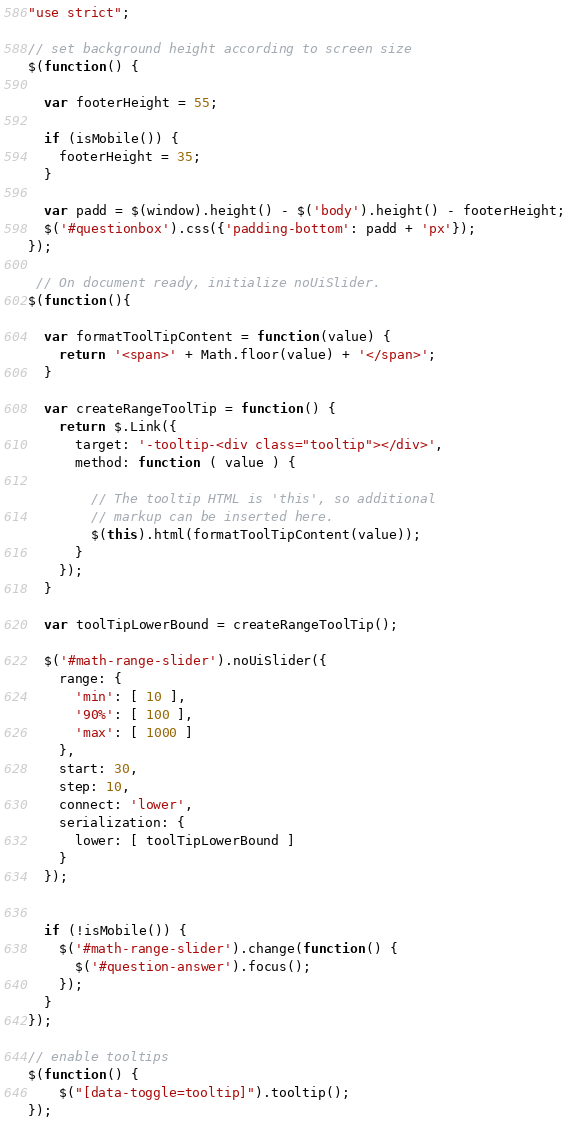<code> <loc_0><loc_0><loc_500><loc_500><_JavaScript_>"use strict";

// set background height according to screen size
$(function() {

  var footerHeight = 55;

  if (isMobile()) {
    footerHeight = 35;
  }

  var padd = $(window).height() - $('body').height() - footerHeight;
  $('#questionbox').css({'padding-bottom': padd + 'px'});
});

 // On document ready, initialize noUiSlider.
$(function(){

  var formatToolTipContent = function(value) {
    return '<span>' + Math.floor(value) + '</span>';
  }

  var createRangeToolTip = function() {
    return $.Link({
      target: '-tooltip-<div class="tooltip"></div>',
      method: function ( value ) {

        // The tooltip HTML is 'this', so additional
        // markup can be inserted here.
        $(this).html(formatToolTipContent(value));
      }
    });
  }

  var toolTipLowerBound = createRangeToolTip();

  $('#math-range-slider').noUiSlider({
    range: {
      'min': [ 10 ],
      '90%': [ 100 ],
      'max': [ 1000 ]
    },
    start: 30,
    step: 10,
    connect: 'lower',
    serialization: {
      lower: [ toolTipLowerBound ]
    }
  });


  if (!isMobile()) {
    $('#math-range-slider').change(function() {
      $('#question-answer').focus();
    });
  }
});

// enable tooltips
$(function() {
    $("[data-toggle=tooltip]").tooltip();
});</code> 